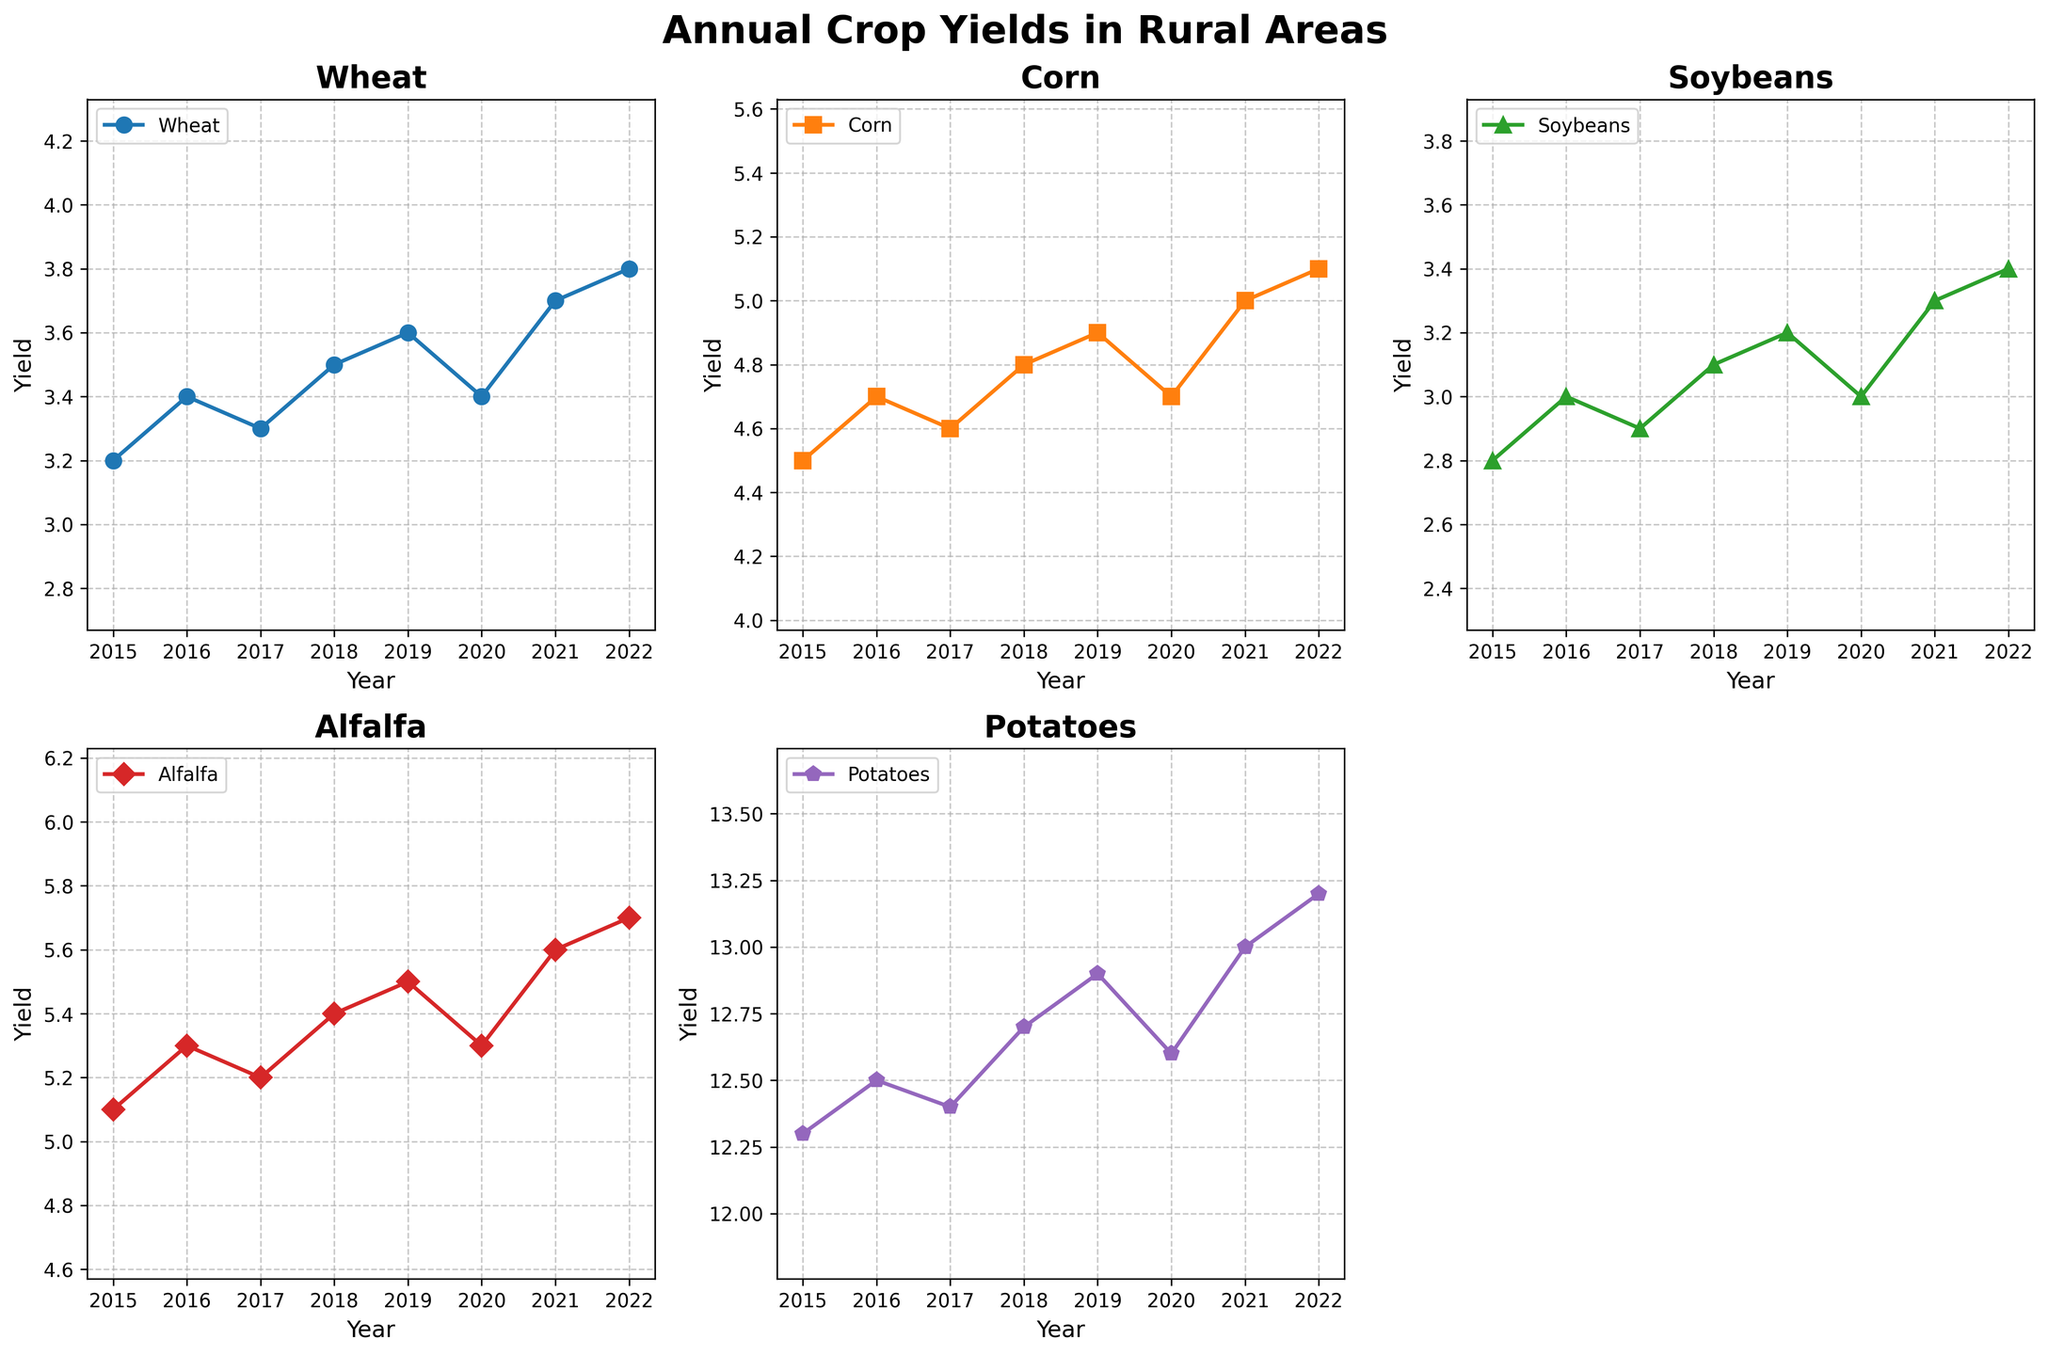What's the title of the overall figure? The overall title of the figure is prominently displayed at the top and states 'Annual Crop Yields in Rural Areas'
Answer: Annual Crop Yields in Rural Areas Which crop type has the highest yield? By examining the height of lines and the labels on the y-axis, Potatoes have the highest yield compared to other crop types
Answer: Potatoes What is the trend in the yield of Corn from 2015 to 2022? The line representing Corn shows an increasing trend from 4.5 in 2015 to 5.1 in 2022, suggesting a steady growth over the years
Answer: Increasing What is the average yield of Wheat over the years? Sum the yields for Wheat (3.2+3.4+3.3+3.5+3.6+3.4+3.7+3.8) and divide by 8; (3.2+3.4+3.3+3.5+3.6+3.4+3.7+3.8) = 27.9, average = 27.9/8
Answer: 3.49 Which two crops have yields that cross each other’s paths the most? Observing the intersections of lines, Alfalfa and Potatoes have yields that intersect more frequently compared to other crops
Answer: Alfalfa and Potatoes What is the difference in yield between Soybeans and Alfalfa in 2020? Subtract the yield of Soybeans (3.0) from Alfalfa (5.3) in the year 2020; 5.3 - 3.0 = 2.3
Answer: 2.3 How many crop types are displayed in the figure? Counting the number of different lines, there are five distinct crop types plotted
Answer: 5 What year shows the highest yield for Alfalfa? Looking at the peaks in the line representing Alfalfa, the highest yield of 5.7 is in the year 2022
Answer: 2022 In which year did Potatoes see no yield increase compared to the previous year? Comparing successive points in the Potatoes line, there is no increase between 2017 (12.4) and 2018 (12.7)
Answer: 2017 Which crop type had the most fluctuation in yield over the years? Observing the variations in line steepness, Corn shows a relatively more consistent increase, while Wheat and Alfalfa exhibit more fluctuations
Answer: Wheat 